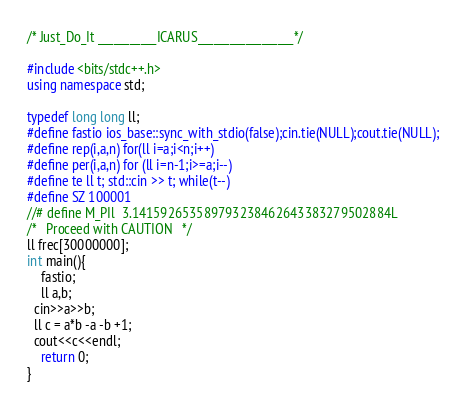Convert code to text. <code><loc_0><loc_0><loc_500><loc_500><_C++_>/* Just_Do_It ___________ICARUS__________________*/
                 
#include <bits/stdc++.h>
using namespace std;
       
typedef long long ll;
#define fastio ios_base::sync_with_stdio(false);cin.tie(NULL);cout.tie(NULL);
#define rep(i,a,n) for(ll i=a;i<n;i++)
#define per(i,a,n) for (ll i=n-1;i>=a;i--)
#define te ll t; std::cin >> t; while(t--)
#define SZ 100001
//# define M_PIl  3.141592653589793238462643383279502884L 
/*   Proceed with CAUTION   */
ll frec[30000000];
int main(){
	fastio;
	ll a,b;
  cin>>a>>b;
  ll c = a*b -a -b +1;
  cout<<c<<endl;
	return 0;
} </code> 